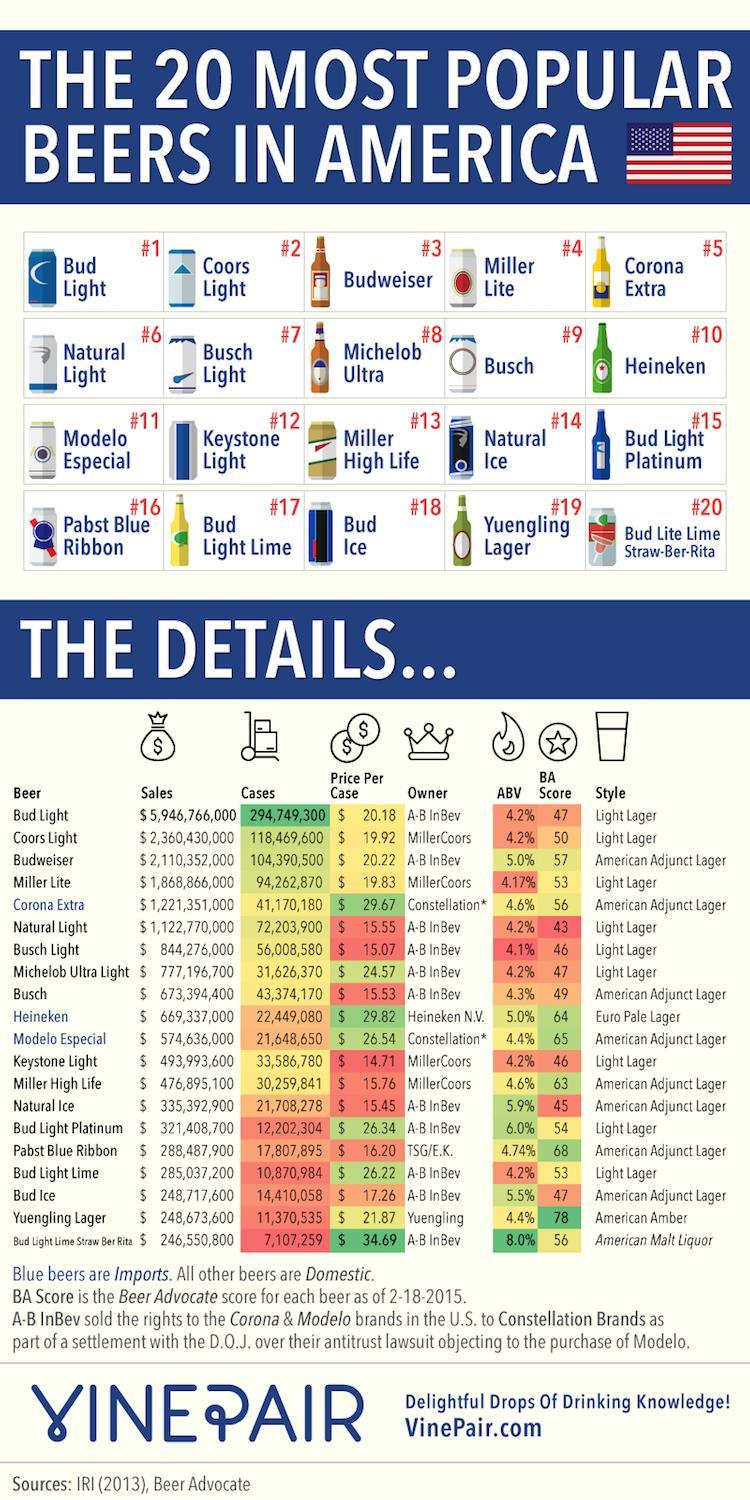what is the total cases for coors light and heineken
Answer the question with a short phrase. 140918680 what is the BA score of Natural light 43 how many beer cans in the third row 4 which beer costs more than Heineken Bud Light Lime Straw Ber Rita who is the owner for Busch and Natural Ice A-B InBev how many beer bottles in the second row 2 